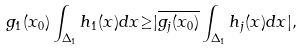<formula> <loc_0><loc_0><loc_500><loc_500>g _ { 1 } ( x _ { 0 } ) \int _ { \Delta _ { 1 } } h _ { 1 } ( x ) d x { \geq } | \overline { g _ { j } ( x _ { 0 } ) } \int _ { \Delta _ { 1 } } h _ { j } ( x ) d x | ,</formula> 